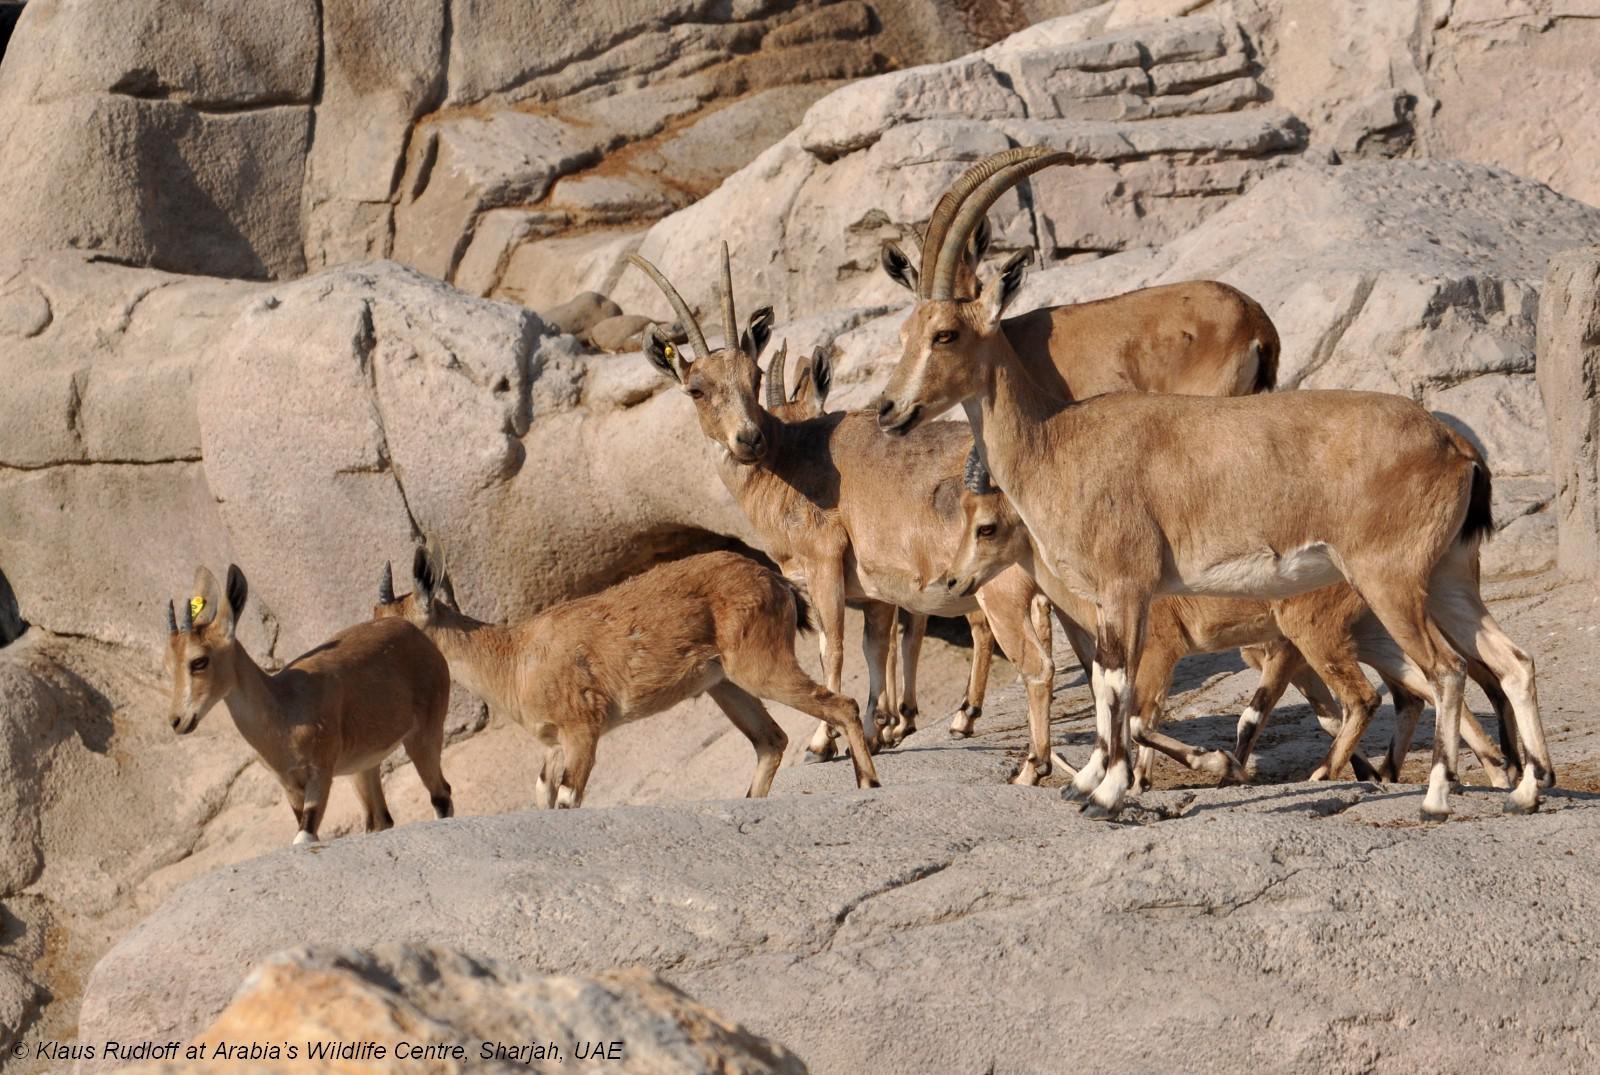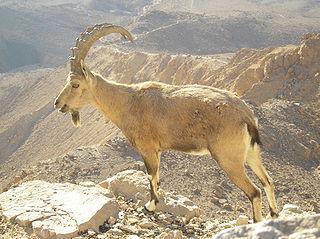The first image is the image on the left, the second image is the image on the right. For the images shown, is this caption "An image shows a person in a hat and camo-patterned top posed next to a long-horned animal." true? Answer yes or no. No. The first image is the image on the left, the second image is the image on the right. Given the left and right images, does the statement "The hunter is near his gun in the image on the right." hold true? Answer yes or no. No. 